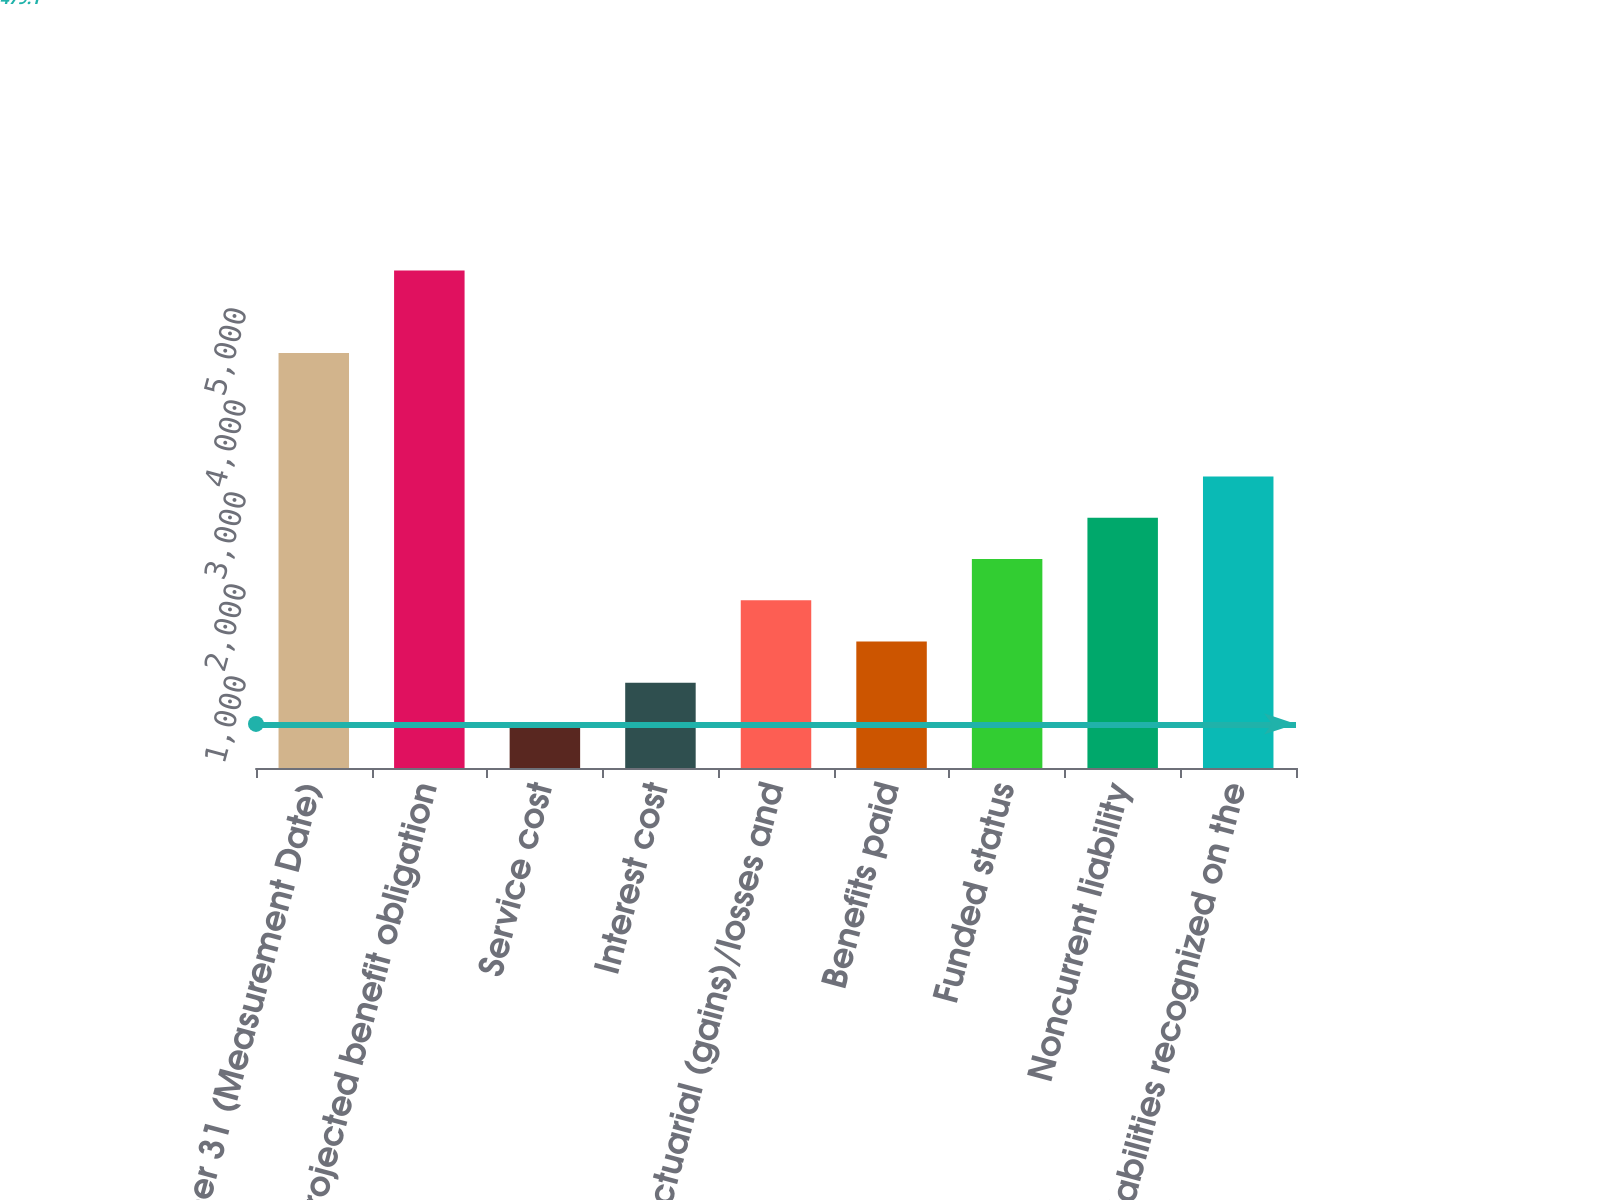<chart> <loc_0><loc_0><loc_500><loc_500><bar_chart><fcel>December 31 (Measurement Date)<fcel>Projected benefit obligation<fcel>Service cost<fcel>Interest cost<fcel>Actuarial (gains)/losses and<fcel>Benefits paid<fcel>Funded status<fcel>Noncurrent liability<fcel>Liabilities recognized on the<nl><fcel>4512<fcel>5408.2<fcel>479.1<fcel>927.2<fcel>1823.4<fcel>1375.3<fcel>2271.5<fcel>2719.6<fcel>3167.7<nl></chart> 